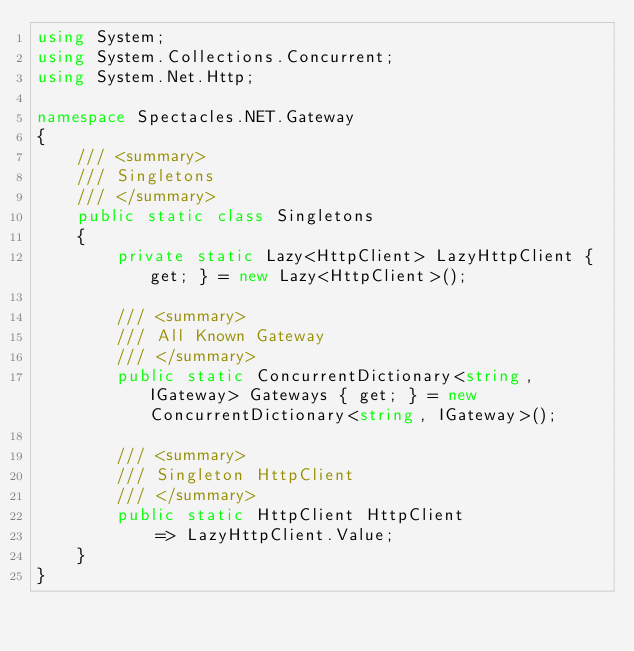<code> <loc_0><loc_0><loc_500><loc_500><_C#_>using System;
using System.Collections.Concurrent;
using System.Net.Http;

namespace Spectacles.NET.Gateway
{
	/// <summary>
	/// Singletons 
	/// </summary>
	public static class Singletons
	{
		private static Lazy<HttpClient> LazyHttpClient { get; } = new Lazy<HttpClient>();
		
		/// <summary>
		/// All Known Gateway
		/// </summary>
		public static ConcurrentDictionary<string, IGateway> Gateways { get; } = new ConcurrentDictionary<string, IGateway>();

		/// <summary>
		/// Singleton HttpClient
		/// </summary>
		public static HttpClient HttpClient
			=> LazyHttpClient.Value;
	}
}
</code> 